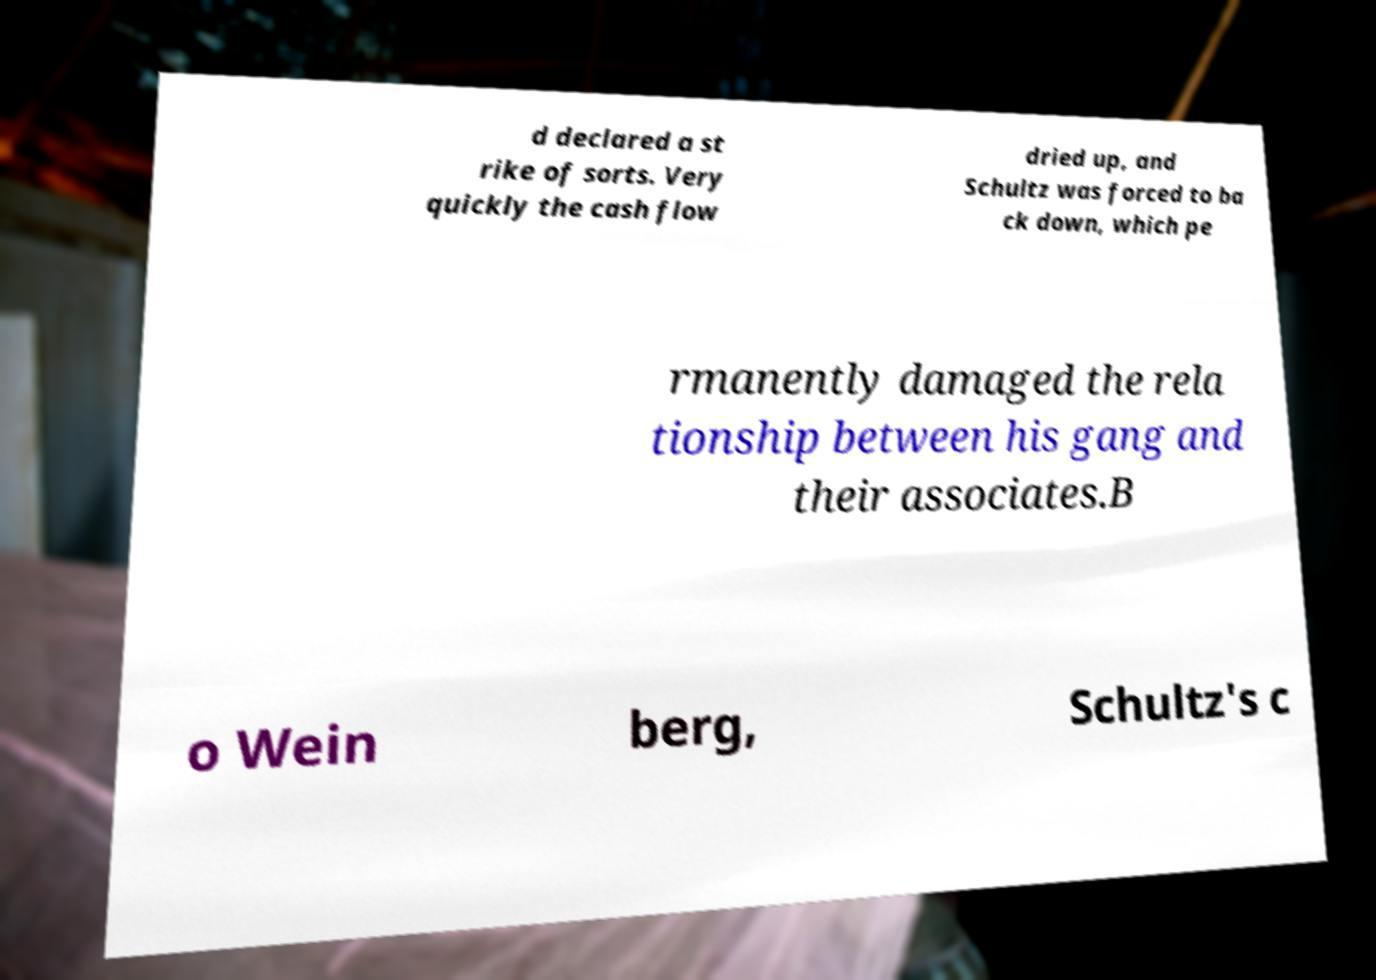Could you assist in decoding the text presented in this image and type it out clearly? d declared a st rike of sorts. Very quickly the cash flow dried up, and Schultz was forced to ba ck down, which pe rmanently damaged the rela tionship between his gang and their associates.B o Wein berg, Schultz's c 